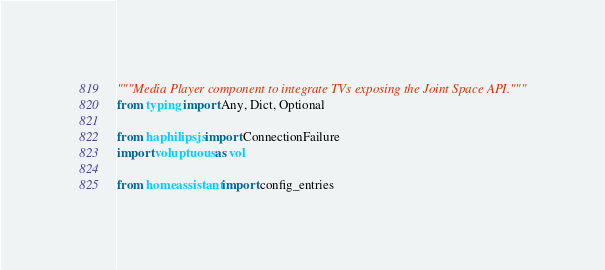Convert code to text. <code><loc_0><loc_0><loc_500><loc_500><_Python_>"""Media Player component to integrate TVs exposing the Joint Space API."""
from typing import Any, Dict, Optional

from haphilipsjs import ConnectionFailure
import voluptuous as vol

from homeassistant import config_entries</code> 